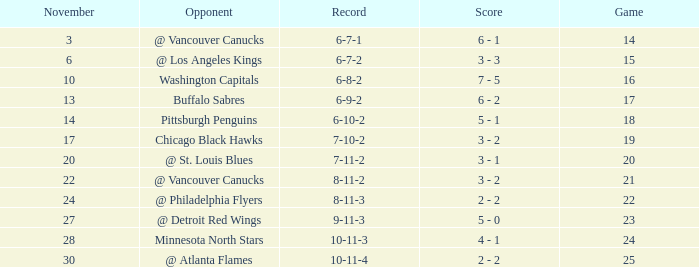What is the game when on november 27? 23.0. 